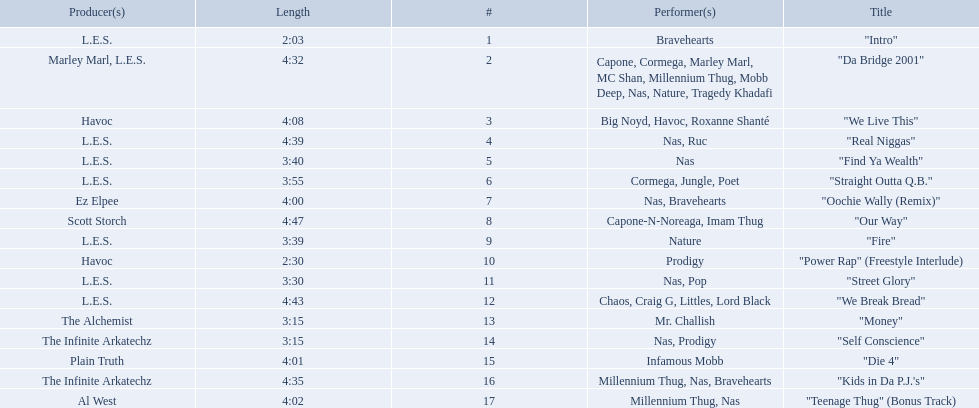How long is each song? 2:03, 4:32, 4:08, 4:39, 3:40, 3:55, 4:00, 4:47, 3:39, 2:30, 3:30, 4:43, 3:15, 3:15, 4:01, 4:35, 4:02. What length is the longest? 4:47. 